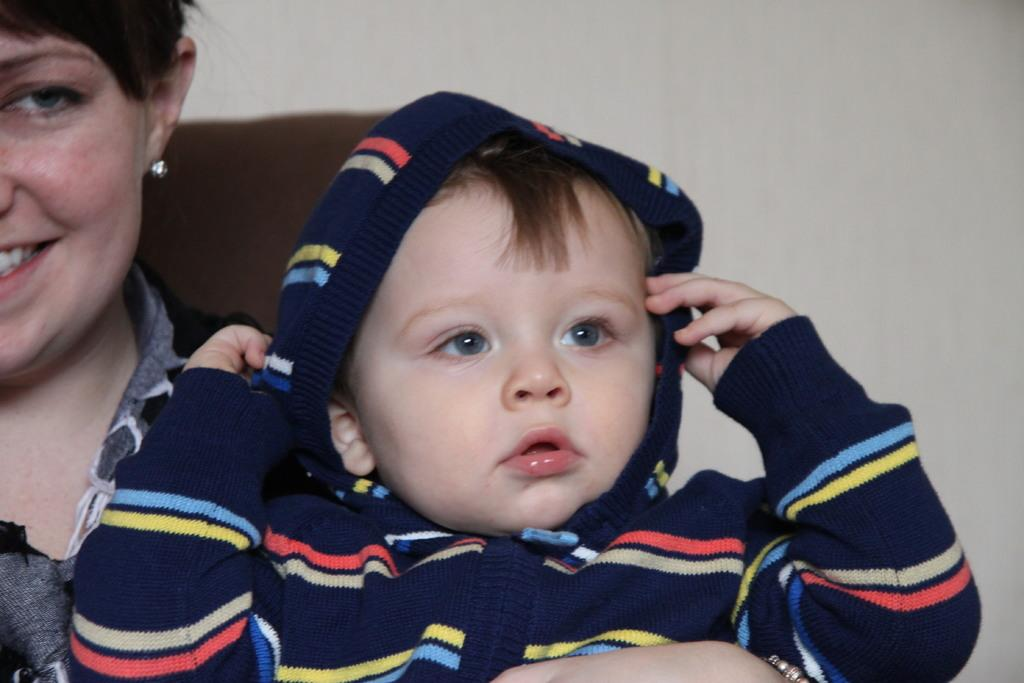Who is the main subject in the image? There is a woman in the image. What is the woman doing in the image? The woman is holding a child in her arms. What can be seen behind the woman? There is a wall behind the woman. What type of fruit is the woman holding in the image? There is no fruit present in the image; the woman is holding a child in her arms. 